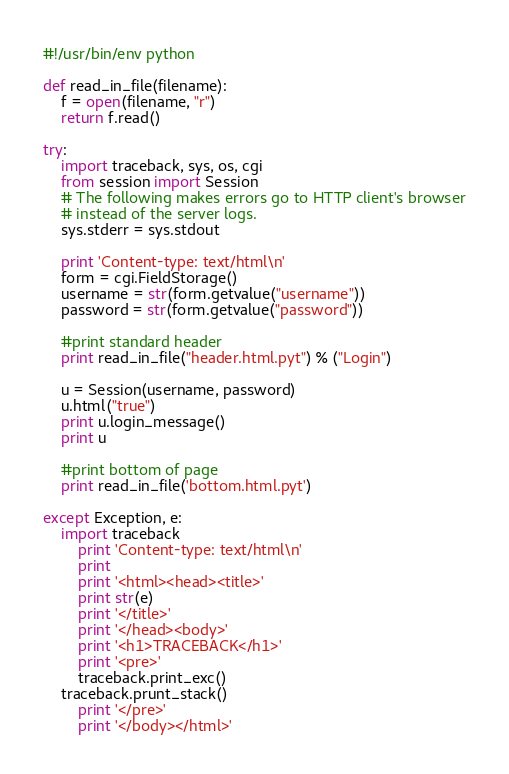<code> <loc_0><loc_0><loc_500><loc_500><_Python_>#!/usr/bin/env python

def read_in_file(filename):
	f = open(filename, "r")
	return f.read()

try:
	import traceback, sys, os, cgi
	from session import Session
	# The following makes errors go to HTTP client's browser
	# instead of the server logs.
	sys.stderr = sys.stdout

	print 'Content-type: text/html\n'
	form = cgi.FieldStorage()
	username = str(form.getvalue("username"))
	password = str(form.getvalue("password"))

	#print standard header
	print read_in_file("header.html.pyt") % ("Login")

	u = Session(username, password)
	u.html("true")
	print u.login_message()
	print u

	#print bottom of page
	print read_in_file('bottom.html.pyt')
        
except Exception, e:
	import traceback
        print 'Content-type: text/html\n'
        print
        print '<html><head><title>'
        print str(e)
        print '</title>'
        print '</head><body>'
        print '<h1>TRACEBACK</h1>'
        print '<pre>'
        traceback.print_exc()
	traceback.prunt_stack()
        print '</pre>'
        print '</body></html>'
</code> 